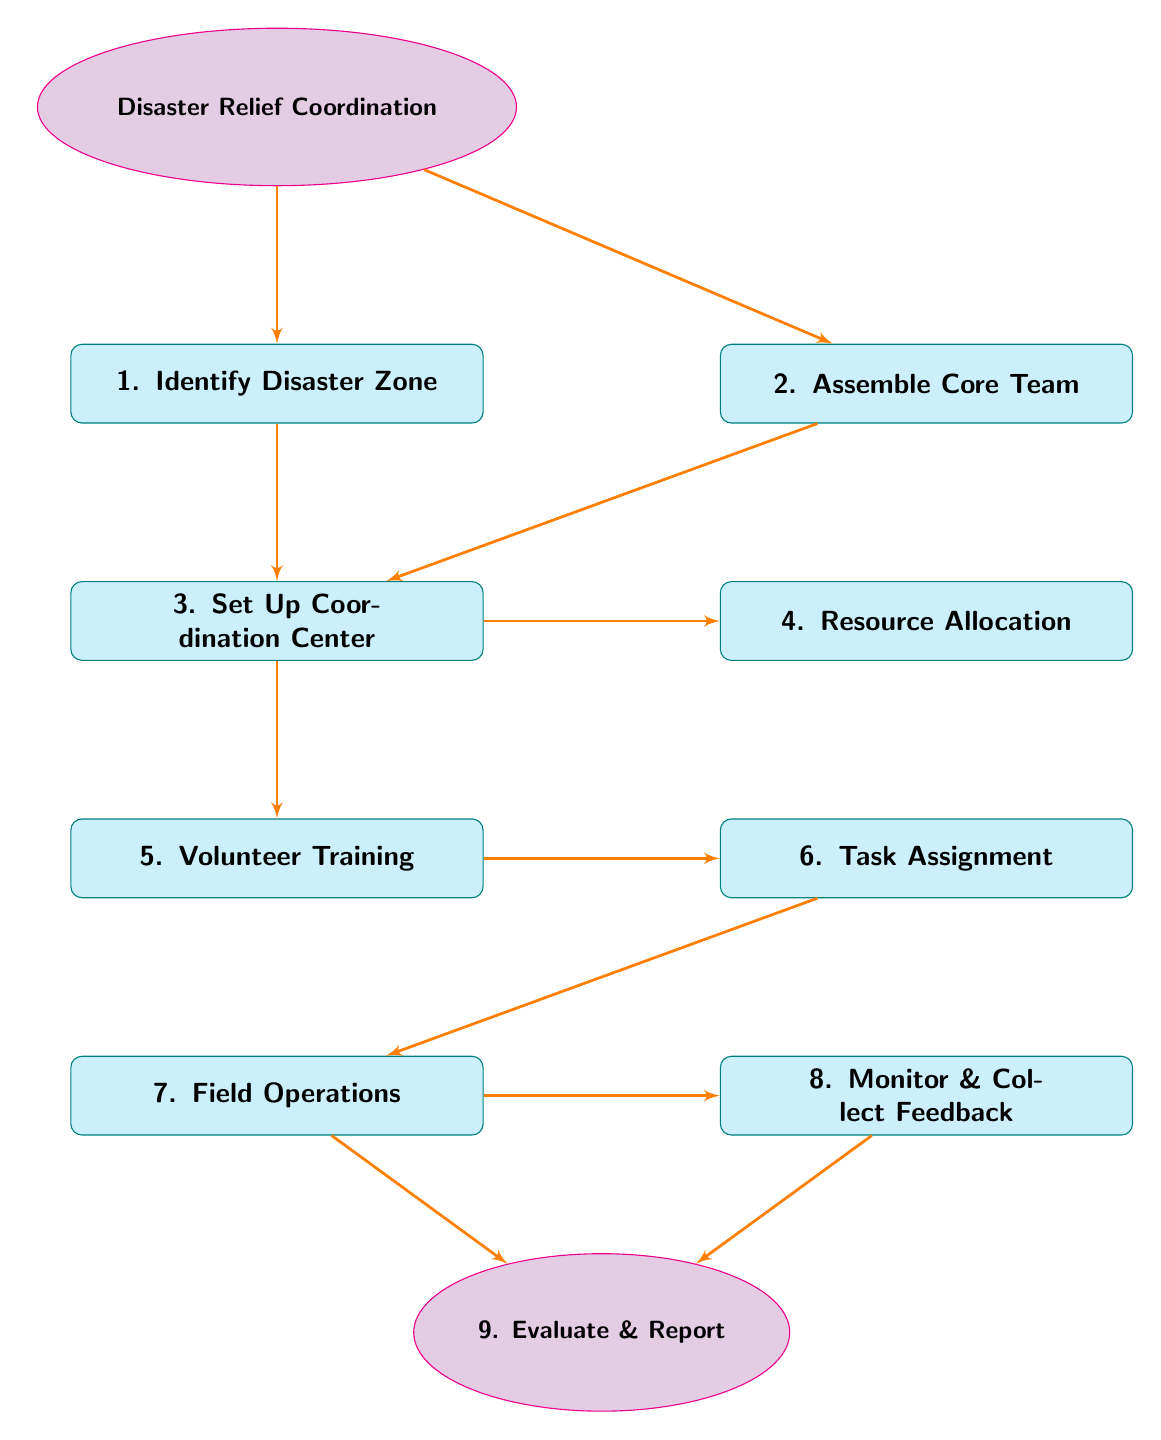What is the first step in the disaster relief coordination process? The diagram indicates that the first step is to "Identify Disaster Zone," which is represented as the topmost block in the flow chart.
Answer: Identify Disaster Zone How many main activities are outlined in the flow chart? Count the main blocks that represent specific activities. There are a total of eight activities (from Identify Disaster Zone to Evaluate & Report) shown in the diagram, excluding the start and end nodes.
Answer: Eight Which node follows "Set Up Coordination Center"? The node that immediately follows "Set Up Coordination Center" is "Resource Allocation," as indicated by the directional line leading directly down to this block.
Answer: Resource Allocation What is the relationship between "Volunteer Training" and "Field Operations"? "Volunteer Training" directly leads to "Field Operations." The diagram shows that after training volunteers, they are assigned tasks (Task Assignment) which then leads to their deployment to operations in the field.
Answer: Direct lead What task occurs after "Task Assignment"? The task that occurs after "Task Assignment" in the flow chart is "Field Operations," indicating that after assigning roles, volunteers will proceed to perform their duties on-site.
Answer: Field Operations How many feedback loops are demonstrated in the flow chart? The flow chart illustrates that feedback is collected after "Field Operations" and is reviewed in "Monitor & Collect Feedback." This signifies a loop back to evaluate how well the operations are functioning. Hence, there is one feedback loop.
Answer: One What is the last step in the disaster relief coordination process? The last step, as shown in the diagram, is "Evaluate & Report," which is positioned below the "Monitor & Collect Feedback" node indicating a concluding review of efforts.
Answer: Evaluate & Report What is the purpose of "Assemble Core Team"? The purpose of "Assemble Core Team" is to gather key community leaders and experienced volunteers, as defined in the block description.
Answer: Gather leaders and volunteers Which two nodes are connected directly to "Set Up Coordination Center"? The two nodes directly connected to "Set Up Coordination Center" are "Resource Allocation" and "Volunteer Training," indicated by the branch lines emanating from the coordination center block.
Answer: Resource Allocation and Volunteer Training 